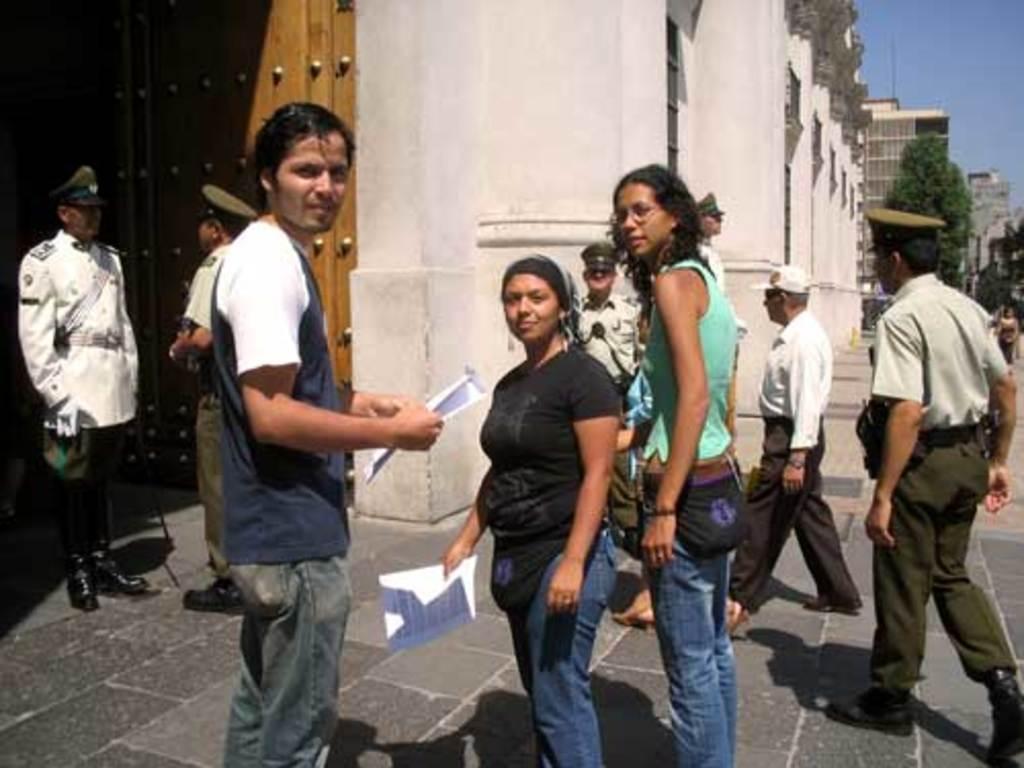Can you describe this image briefly? In the image few people are standing and walking and holding some papers. Behind them there are some trees and buildings. In the top right corner of the image there is sky. 